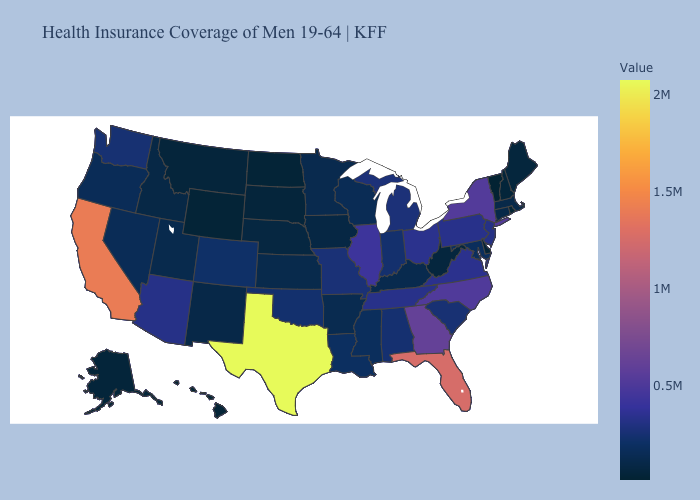Does Texas have the highest value in the USA?
Write a very short answer. Yes. Does Alaska have a higher value than New York?
Be succinct. No. Which states have the lowest value in the South?
Be succinct. Delaware. Among the states that border Texas , does New Mexico have the lowest value?
Concise answer only. Yes. Does the map have missing data?
Answer briefly. No. Does the map have missing data?
Be succinct. No. Among the states that border Rhode Island , which have the lowest value?
Answer briefly. Connecticut. 